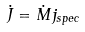<formula> <loc_0><loc_0><loc_500><loc_500>\dot { J } = \dot { M } j _ { s p e c }</formula> 